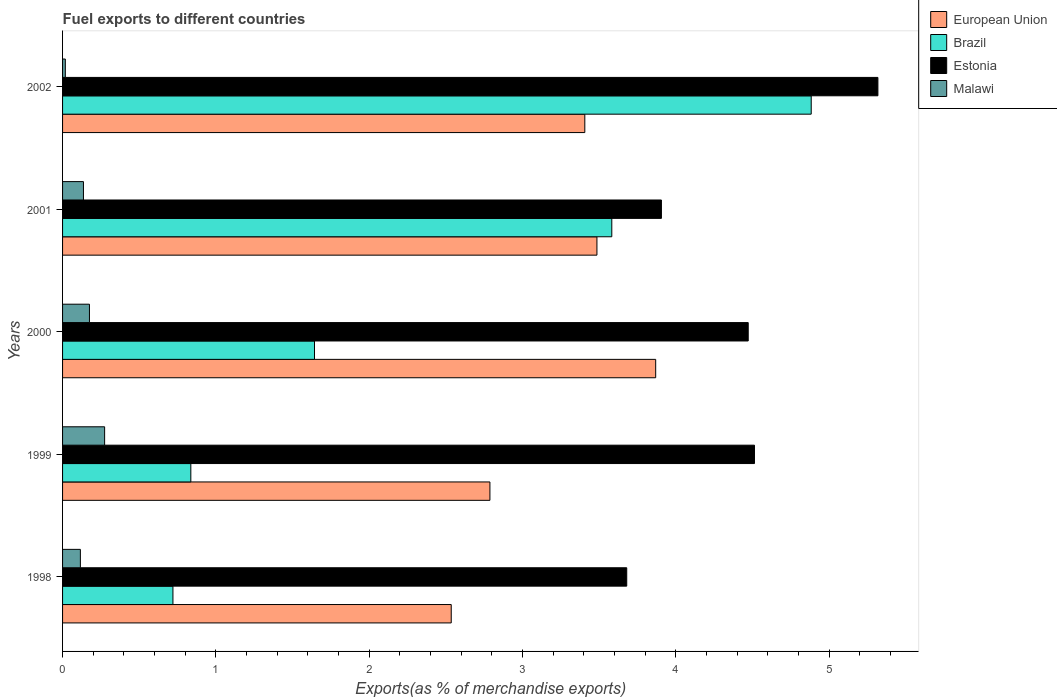Are the number of bars on each tick of the Y-axis equal?
Provide a short and direct response. Yes. How many bars are there on the 2nd tick from the bottom?
Offer a terse response. 4. In how many cases, is the number of bars for a given year not equal to the number of legend labels?
Provide a short and direct response. 0. What is the percentage of exports to different countries in European Union in 2000?
Ensure brevity in your answer.  3.87. Across all years, what is the maximum percentage of exports to different countries in European Union?
Your answer should be compact. 3.87. Across all years, what is the minimum percentage of exports to different countries in Malawi?
Keep it short and to the point. 0.02. In which year was the percentage of exports to different countries in Estonia minimum?
Your answer should be compact. 1998. What is the total percentage of exports to different countries in European Union in the graph?
Provide a succinct answer. 16.08. What is the difference between the percentage of exports to different countries in Brazil in 1998 and that in 2000?
Give a very brief answer. -0.92. What is the difference between the percentage of exports to different countries in Brazil in 1998 and the percentage of exports to different countries in Malawi in 2002?
Your answer should be compact. 0.7. What is the average percentage of exports to different countries in European Union per year?
Offer a very short reply. 3.22. In the year 2000, what is the difference between the percentage of exports to different countries in Malawi and percentage of exports to different countries in European Union?
Your answer should be compact. -3.69. In how many years, is the percentage of exports to different countries in Malawi greater than 2.6 %?
Provide a short and direct response. 0. What is the ratio of the percentage of exports to different countries in European Union in 1998 to that in 2000?
Provide a succinct answer. 0.66. Is the percentage of exports to different countries in Estonia in 2000 less than that in 2002?
Make the answer very short. Yes. What is the difference between the highest and the second highest percentage of exports to different countries in Malawi?
Offer a terse response. 0.1. What is the difference between the highest and the lowest percentage of exports to different countries in Malawi?
Give a very brief answer. 0.26. Is it the case that in every year, the sum of the percentage of exports to different countries in Brazil and percentage of exports to different countries in European Union is greater than the sum of percentage of exports to different countries in Estonia and percentage of exports to different countries in Malawi?
Offer a very short reply. No. What does the 4th bar from the top in 2000 represents?
Ensure brevity in your answer.  European Union. What does the 3rd bar from the bottom in 2000 represents?
Provide a short and direct response. Estonia. What is the difference between two consecutive major ticks on the X-axis?
Your answer should be compact. 1. Does the graph contain any zero values?
Offer a terse response. No. Does the graph contain grids?
Your response must be concise. No. Where does the legend appear in the graph?
Your response must be concise. Top right. How many legend labels are there?
Offer a terse response. 4. What is the title of the graph?
Your response must be concise. Fuel exports to different countries. What is the label or title of the X-axis?
Provide a succinct answer. Exports(as % of merchandise exports). What is the label or title of the Y-axis?
Keep it short and to the point. Years. What is the Exports(as % of merchandise exports) in European Union in 1998?
Make the answer very short. 2.54. What is the Exports(as % of merchandise exports) in Brazil in 1998?
Keep it short and to the point. 0.72. What is the Exports(as % of merchandise exports) of Estonia in 1998?
Your response must be concise. 3.68. What is the Exports(as % of merchandise exports) in Malawi in 1998?
Provide a succinct answer. 0.12. What is the Exports(as % of merchandise exports) of European Union in 1999?
Your answer should be compact. 2.79. What is the Exports(as % of merchandise exports) in Brazil in 1999?
Offer a very short reply. 0.84. What is the Exports(as % of merchandise exports) of Estonia in 1999?
Keep it short and to the point. 4.51. What is the Exports(as % of merchandise exports) of Malawi in 1999?
Offer a very short reply. 0.27. What is the Exports(as % of merchandise exports) of European Union in 2000?
Provide a succinct answer. 3.87. What is the Exports(as % of merchandise exports) of Brazil in 2000?
Your response must be concise. 1.64. What is the Exports(as % of merchandise exports) of Estonia in 2000?
Provide a succinct answer. 4.47. What is the Exports(as % of merchandise exports) in Malawi in 2000?
Provide a short and direct response. 0.18. What is the Exports(as % of merchandise exports) of European Union in 2001?
Make the answer very short. 3.49. What is the Exports(as % of merchandise exports) of Brazil in 2001?
Your answer should be very brief. 3.58. What is the Exports(as % of merchandise exports) of Estonia in 2001?
Your response must be concise. 3.91. What is the Exports(as % of merchandise exports) in Malawi in 2001?
Make the answer very short. 0.14. What is the Exports(as % of merchandise exports) of European Union in 2002?
Keep it short and to the point. 3.41. What is the Exports(as % of merchandise exports) in Brazil in 2002?
Keep it short and to the point. 4.88. What is the Exports(as % of merchandise exports) in Estonia in 2002?
Provide a succinct answer. 5.32. What is the Exports(as % of merchandise exports) of Malawi in 2002?
Ensure brevity in your answer.  0.02. Across all years, what is the maximum Exports(as % of merchandise exports) of European Union?
Keep it short and to the point. 3.87. Across all years, what is the maximum Exports(as % of merchandise exports) of Brazil?
Your answer should be very brief. 4.88. Across all years, what is the maximum Exports(as % of merchandise exports) of Estonia?
Your answer should be very brief. 5.32. Across all years, what is the maximum Exports(as % of merchandise exports) of Malawi?
Your answer should be compact. 0.27. Across all years, what is the minimum Exports(as % of merchandise exports) of European Union?
Make the answer very short. 2.54. Across all years, what is the minimum Exports(as % of merchandise exports) in Brazil?
Keep it short and to the point. 0.72. Across all years, what is the minimum Exports(as % of merchandise exports) of Estonia?
Your answer should be compact. 3.68. Across all years, what is the minimum Exports(as % of merchandise exports) of Malawi?
Make the answer very short. 0.02. What is the total Exports(as % of merchandise exports) of European Union in the graph?
Keep it short and to the point. 16.08. What is the total Exports(as % of merchandise exports) in Brazil in the graph?
Make the answer very short. 11.67. What is the total Exports(as % of merchandise exports) of Estonia in the graph?
Ensure brevity in your answer.  21.89. What is the total Exports(as % of merchandise exports) in Malawi in the graph?
Provide a succinct answer. 0.72. What is the difference between the Exports(as % of merchandise exports) in European Union in 1998 and that in 1999?
Make the answer very short. -0.25. What is the difference between the Exports(as % of merchandise exports) in Brazil in 1998 and that in 1999?
Provide a succinct answer. -0.12. What is the difference between the Exports(as % of merchandise exports) in Estonia in 1998 and that in 1999?
Offer a very short reply. -0.83. What is the difference between the Exports(as % of merchandise exports) in Malawi in 1998 and that in 1999?
Your answer should be very brief. -0.16. What is the difference between the Exports(as % of merchandise exports) in European Union in 1998 and that in 2000?
Provide a succinct answer. -1.33. What is the difference between the Exports(as % of merchandise exports) in Brazil in 1998 and that in 2000?
Ensure brevity in your answer.  -0.92. What is the difference between the Exports(as % of merchandise exports) of Estonia in 1998 and that in 2000?
Your response must be concise. -0.79. What is the difference between the Exports(as % of merchandise exports) in Malawi in 1998 and that in 2000?
Offer a very short reply. -0.06. What is the difference between the Exports(as % of merchandise exports) in European Union in 1998 and that in 2001?
Make the answer very short. -0.95. What is the difference between the Exports(as % of merchandise exports) of Brazil in 1998 and that in 2001?
Ensure brevity in your answer.  -2.86. What is the difference between the Exports(as % of merchandise exports) in Estonia in 1998 and that in 2001?
Offer a terse response. -0.23. What is the difference between the Exports(as % of merchandise exports) in Malawi in 1998 and that in 2001?
Your answer should be very brief. -0.02. What is the difference between the Exports(as % of merchandise exports) of European Union in 1998 and that in 2002?
Keep it short and to the point. -0.87. What is the difference between the Exports(as % of merchandise exports) of Brazil in 1998 and that in 2002?
Your answer should be compact. -4.16. What is the difference between the Exports(as % of merchandise exports) in Estonia in 1998 and that in 2002?
Provide a succinct answer. -1.64. What is the difference between the Exports(as % of merchandise exports) in Malawi in 1998 and that in 2002?
Give a very brief answer. 0.1. What is the difference between the Exports(as % of merchandise exports) in European Union in 1999 and that in 2000?
Provide a short and direct response. -1.08. What is the difference between the Exports(as % of merchandise exports) of Brazil in 1999 and that in 2000?
Give a very brief answer. -0.81. What is the difference between the Exports(as % of merchandise exports) in Estonia in 1999 and that in 2000?
Ensure brevity in your answer.  0.04. What is the difference between the Exports(as % of merchandise exports) in Malawi in 1999 and that in 2000?
Offer a very short reply. 0.1. What is the difference between the Exports(as % of merchandise exports) in European Union in 1999 and that in 2001?
Keep it short and to the point. -0.7. What is the difference between the Exports(as % of merchandise exports) of Brazil in 1999 and that in 2001?
Offer a terse response. -2.75. What is the difference between the Exports(as % of merchandise exports) in Estonia in 1999 and that in 2001?
Your answer should be very brief. 0.61. What is the difference between the Exports(as % of merchandise exports) of Malawi in 1999 and that in 2001?
Provide a succinct answer. 0.14. What is the difference between the Exports(as % of merchandise exports) in European Union in 1999 and that in 2002?
Your response must be concise. -0.62. What is the difference between the Exports(as % of merchandise exports) in Brazil in 1999 and that in 2002?
Your answer should be very brief. -4.05. What is the difference between the Exports(as % of merchandise exports) in Estonia in 1999 and that in 2002?
Provide a succinct answer. -0.81. What is the difference between the Exports(as % of merchandise exports) of Malawi in 1999 and that in 2002?
Provide a succinct answer. 0.26. What is the difference between the Exports(as % of merchandise exports) of European Union in 2000 and that in 2001?
Offer a very short reply. 0.38. What is the difference between the Exports(as % of merchandise exports) of Brazil in 2000 and that in 2001?
Ensure brevity in your answer.  -1.94. What is the difference between the Exports(as % of merchandise exports) of Estonia in 2000 and that in 2001?
Your response must be concise. 0.57. What is the difference between the Exports(as % of merchandise exports) in Malawi in 2000 and that in 2001?
Ensure brevity in your answer.  0.04. What is the difference between the Exports(as % of merchandise exports) in European Union in 2000 and that in 2002?
Keep it short and to the point. 0.46. What is the difference between the Exports(as % of merchandise exports) in Brazil in 2000 and that in 2002?
Keep it short and to the point. -3.24. What is the difference between the Exports(as % of merchandise exports) of Estonia in 2000 and that in 2002?
Your answer should be compact. -0.85. What is the difference between the Exports(as % of merchandise exports) of Malawi in 2000 and that in 2002?
Give a very brief answer. 0.16. What is the difference between the Exports(as % of merchandise exports) in European Union in 2001 and that in 2002?
Your answer should be very brief. 0.08. What is the difference between the Exports(as % of merchandise exports) in Brazil in 2001 and that in 2002?
Keep it short and to the point. -1.3. What is the difference between the Exports(as % of merchandise exports) in Estonia in 2001 and that in 2002?
Give a very brief answer. -1.41. What is the difference between the Exports(as % of merchandise exports) of Malawi in 2001 and that in 2002?
Provide a succinct answer. 0.12. What is the difference between the Exports(as % of merchandise exports) in European Union in 1998 and the Exports(as % of merchandise exports) in Brazil in 1999?
Your response must be concise. 1.7. What is the difference between the Exports(as % of merchandise exports) in European Union in 1998 and the Exports(as % of merchandise exports) in Estonia in 1999?
Your response must be concise. -1.98. What is the difference between the Exports(as % of merchandise exports) in European Union in 1998 and the Exports(as % of merchandise exports) in Malawi in 1999?
Keep it short and to the point. 2.26. What is the difference between the Exports(as % of merchandise exports) in Brazil in 1998 and the Exports(as % of merchandise exports) in Estonia in 1999?
Provide a short and direct response. -3.79. What is the difference between the Exports(as % of merchandise exports) of Brazil in 1998 and the Exports(as % of merchandise exports) of Malawi in 1999?
Your answer should be compact. 0.45. What is the difference between the Exports(as % of merchandise exports) in Estonia in 1998 and the Exports(as % of merchandise exports) in Malawi in 1999?
Provide a short and direct response. 3.41. What is the difference between the Exports(as % of merchandise exports) in European Union in 1998 and the Exports(as % of merchandise exports) in Brazil in 2000?
Give a very brief answer. 0.89. What is the difference between the Exports(as % of merchandise exports) of European Union in 1998 and the Exports(as % of merchandise exports) of Estonia in 2000?
Provide a succinct answer. -1.94. What is the difference between the Exports(as % of merchandise exports) of European Union in 1998 and the Exports(as % of merchandise exports) of Malawi in 2000?
Provide a succinct answer. 2.36. What is the difference between the Exports(as % of merchandise exports) in Brazil in 1998 and the Exports(as % of merchandise exports) in Estonia in 2000?
Offer a very short reply. -3.75. What is the difference between the Exports(as % of merchandise exports) in Brazil in 1998 and the Exports(as % of merchandise exports) in Malawi in 2000?
Provide a succinct answer. 0.54. What is the difference between the Exports(as % of merchandise exports) in Estonia in 1998 and the Exports(as % of merchandise exports) in Malawi in 2000?
Offer a very short reply. 3.5. What is the difference between the Exports(as % of merchandise exports) of European Union in 1998 and the Exports(as % of merchandise exports) of Brazil in 2001?
Your answer should be compact. -1.05. What is the difference between the Exports(as % of merchandise exports) in European Union in 1998 and the Exports(as % of merchandise exports) in Estonia in 2001?
Your response must be concise. -1.37. What is the difference between the Exports(as % of merchandise exports) of European Union in 1998 and the Exports(as % of merchandise exports) of Malawi in 2001?
Ensure brevity in your answer.  2.4. What is the difference between the Exports(as % of merchandise exports) in Brazil in 1998 and the Exports(as % of merchandise exports) in Estonia in 2001?
Make the answer very short. -3.19. What is the difference between the Exports(as % of merchandise exports) in Brazil in 1998 and the Exports(as % of merchandise exports) in Malawi in 2001?
Offer a very short reply. 0.58. What is the difference between the Exports(as % of merchandise exports) in Estonia in 1998 and the Exports(as % of merchandise exports) in Malawi in 2001?
Offer a terse response. 3.54. What is the difference between the Exports(as % of merchandise exports) in European Union in 1998 and the Exports(as % of merchandise exports) in Brazil in 2002?
Your answer should be very brief. -2.35. What is the difference between the Exports(as % of merchandise exports) of European Union in 1998 and the Exports(as % of merchandise exports) of Estonia in 2002?
Your answer should be very brief. -2.78. What is the difference between the Exports(as % of merchandise exports) in European Union in 1998 and the Exports(as % of merchandise exports) in Malawi in 2002?
Offer a very short reply. 2.52. What is the difference between the Exports(as % of merchandise exports) in Brazil in 1998 and the Exports(as % of merchandise exports) in Estonia in 2002?
Your answer should be very brief. -4.6. What is the difference between the Exports(as % of merchandise exports) in Brazil in 1998 and the Exports(as % of merchandise exports) in Malawi in 2002?
Give a very brief answer. 0.7. What is the difference between the Exports(as % of merchandise exports) in Estonia in 1998 and the Exports(as % of merchandise exports) in Malawi in 2002?
Keep it short and to the point. 3.66. What is the difference between the Exports(as % of merchandise exports) in European Union in 1999 and the Exports(as % of merchandise exports) in Brazil in 2000?
Provide a short and direct response. 1.14. What is the difference between the Exports(as % of merchandise exports) of European Union in 1999 and the Exports(as % of merchandise exports) of Estonia in 2000?
Make the answer very short. -1.68. What is the difference between the Exports(as % of merchandise exports) in European Union in 1999 and the Exports(as % of merchandise exports) in Malawi in 2000?
Provide a succinct answer. 2.61. What is the difference between the Exports(as % of merchandise exports) of Brazil in 1999 and the Exports(as % of merchandise exports) of Estonia in 2000?
Keep it short and to the point. -3.64. What is the difference between the Exports(as % of merchandise exports) in Brazil in 1999 and the Exports(as % of merchandise exports) in Malawi in 2000?
Offer a terse response. 0.66. What is the difference between the Exports(as % of merchandise exports) in Estonia in 1999 and the Exports(as % of merchandise exports) in Malawi in 2000?
Your answer should be very brief. 4.34. What is the difference between the Exports(as % of merchandise exports) of European Union in 1999 and the Exports(as % of merchandise exports) of Brazil in 2001?
Offer a very short reply. -0.79. What is the difference between the Exports(as % of merchandise exports) in European Union in 1999 and the Exports(as % of merchandise exports) in Estonia in 2001?
Offer a very short reply. -1.12. What is the difference between the Exports(as % of merchandise exports) of European Union in 1999 and the Exports(as % of merchandise exports) of Malawi in 2001?
Provide a short and direct response. 2.65. What is the difference between the Exports(as % of merchandise exports) of Brazil in 1999 and the Exports(as % of merchandise exports) of Estonia in 2001?
Keep it short and to the point. -3.07. What is the difference between the Exports(as % of merchandise exports) of Brazil in 1999 and the Exports(as % of merchandise exports) of Malawi in 2001?
Your answer should be compact. 0.7. What is the difference between the Exports(as % of merchandise exports) in Estonia in 1999 and the Exports(as % of merchandise exports) in Malawi in 2001?
Your answer should be compact. 4.38. What is the difference between the Exports(as % of merchandise exports) of European Union in 1999 and the Exports(as % of merchandise exports) of Brazil in 2002?
Keep it short and to the point. -2.1. What is the difference between the Exports(as % of merchandise exports) of European Union in 1999 and the Exports(as % of merchandise exports) of Estonia in 2002?
Your answer should be very brief. -2.53. What is the difference between the Exports(as % of merchandise exports) in European Union in 1999 and the Exports(as % of merchandise exports) in Malawi in 2002?
Offer a very short reply. 2.77. What is the difference between the Exports(as % of merchandise exports) of Brazil in 1999 and the Exports(as % of merchandise exports) of Estonia in 2002?
Provide a short and direct response. -4.48. What is the difference between the Exports(as % of merchandise exports) in Brazil in 1999 and the Exports(as % of merchandise exports) in Malawi in 2002?
Provide a succinct answer. 0.82. What is the difference between the Exports(as % of merchandise exports) in Estonia in 1999 and the Exports(as % of merchandise exports) in Malawi in 2002?
Make the answer very short. 4.5. What is the difference between the Exports(as % of merchandise exports) in European Union in 2000 and the Exports(as % of merchandise exports) in Brazil in 2001?
Make the answer very short. 0.29. What is the difference between the Exports(as % of merchandise exports) in European Union in 2000 and the Exports(as % of merchandise exports) in Estonia in 2001?
Offer a terse response. -0.04. What is the difference between the Exports(as % of merchandise exports) of European Union in 2000 and the Exports(as % of merchandise exports) of Malawi in 2001?
Offer a very short reply. 3.73. What is the difference between the Exports(as % of merchandise exports) of Brazil in 2000 and the Exports(as % of merchandise exports) of Estonia in 2001?
Give a very brief answer. -2.26. What is the difference between the Exports(as % of merchandise exports) in Brazil in 2000 and the Exports(as % of merchandise exports) in Malawi in 2001?
Provide a succinct answer. 1.51. What is the difference between the Exports(as % of merchandise exports) in Estonia in 2000 and the Exports(as % of merchandise exports) in Malawi in 2001?
Offer a terse response. 4.34. What is the difference between the Exports(as % of merchandise exports) of European Union in 2000 and the Exports(as % of merchandise exports) of Brazil in 2002?
Give a very brief answer. -1.01. What is the difference between the Exports(as % of merchandise exports) of European Union in 2000 and the Exports(as % of merchandise exports) of Estonia in 2002?
Keep it short and to the point. -1.45. What is the difference between the Exports(as % of merchandise exports) of European Union in 2000 and the Exports(as % of merchandise exports) of Malawi in 2002?
Provide a succinct answer. 3.85. What is the difference between the Exports(as % of merchandise exports) of Brazil in 2000 and the Exports(as % of merchandise exports) of Estonia in 2002?
Keep it short and to the point. -3.68. What is the difference between the Exports(as % of merchandise exports) in Brazil in 2000 and the Exports(as % of merchandise exports) in Malawi in 2002?
Ensure brevity in your answer.  1.63. What is the difference between the Exports(as % of merchandise exports) of Estonia in 2000 and the Exports(as % of merchandise exports) of Malawi in 2002?
Your response must be concise. 4.45. What is the difference between the Exports(as % of merchandise exports) in European Union in 2001 and the Exports(as % of merchandise exports) in Brazil in 2002?
Offer a terse response. -1.4. What is the difference between the Exports(as % of merchandise exports) of European Union in 2001 and the Exports(as % of merchandise exports) of Estonia in 2002?
Provide a short and direct response. -1.83. What is the difference between the Exports(as % of merchandise exports) in European Union in 2001 and the Exports(as % of merchandise exports) in Malawi in 2002?
Offer a very short reply. 3.47. What is the difference between the Exports(as % of merchandise exports) of Brazil in 2001 and the Exports(as % of merchandise exports) of Estonia in 2002?
Make the answer very short. -1.74. What is the difference between the Exports(as % of merchandise exports) of Brazil in 2001 and the Exports(as % of merchandise exports) of Malawi in 2002?
Make the answer very short. 3.56. What is the difference between the Exports(as % of merchandise exports) of Estonia in 2001 and the Exports(as % of merchandise exports) of Malawi in 2002?
Your answer should be compact. 3.89. What is the average Exports(as % of merchandise exports) of European Union per year?
Your answer should be very brief. 3.22. What is the average Exports(as % of merchandise exports) in Brazil per year?
Ensure brevity in your answer.  2.33. What is the average Exports(as % of merchandise exports) in Estonia per year?
Your answer should be very brief. 4.38. What is the average Exports(as % of merchandise exports) of Malawi per year?
Your answer should be very brief. 0.14. In the year 1998, what is the difference between the Exports(as % of merchandise exports) in European Union and Exports(as % of merchandise exports) in Brazil?
Your response must be concise. 1.82. In the year 1998, what is the difference between the Exports(as % of merchandise exports) in European Union and Exports(as % of merchandise exports) in Estonia?
Make the answer very short. -1.14. In the year 1998, what is the difference between the Exports(as % of merchandise exports) of European Union and Exports(as % of merchandise exports) of Malawi?
Your answer should be compact. 2.42. In the year 1998, what is the difference between the Exports(as % of merchandise exports) in Brazil and Exports(as % of merchandise exports) in Estonia?
Provide a succinct answer. -2.96. In the year 1998, what is the difference between the Exports(as % of merchandise exports) in Brazil and Exports(as % of merchandise exports) in Malawi?
Provide a succinct answer. 0.6. In the year 1998, what is the difference between the Exports(as % of merchandise exports) of Estonia and Exports(as % of merchandise exports) of Malawi?
Your response must be concise. 3.56. In the year 1999, what is the difference between the Exports(as % of merchandise exports) in European Union and Exports(as % of merchandise exports) in Brazil?
Give a very brief answer. 1.95. In the year 1999, what is the difference between the Exports(as % of merchandise exports) of European Union and Exports(as % of merchandise exports) of Estonia?
Make the answer very short. -1.73. In the year 1999, what is the difference between the Exports(as % of merchandise exports) of European Union and Exports(as % of merchandise exports) of Malawi?
Provide a short and direct response. 2.51. In the year 1999, what is the difference between the Exports(as % of merchandise exports) in Brazil and Exports(as % of merchandise exports) in Estonia?
Your response must be concise. -3.68. In the year 1999, what is the difference between the Exports(as % of merchandise exports) in Brazil and Exports(as % of merchandise exports) in Malawi?
Provide a succinct answer. 0.56. In the year 1999, what is the difference between the Exports(as % of merchandise exports) in Estonia and Exports(as % of merchandise exports) in Malawi?
Your response must be concise. 4.24. In the year 2000, what is the difference between the Exports(as % of merchandise exports) in European Union and Exports(as % of merchandise exports) in Brazil?
Make the answer very short. 2.23. In the year 2000, what is the difference between the Exports(as % of merchandise exports) in European Union and Exports(as % of merchandise exports) in Estonia?
Give a very brief answer. -0.6. In the year 2000, what is the difference between the Exports(as % of merchandise exports) of European Union and Exports(as % of merchandise exports) of Malawi?
Provide a short and direct response. 3.69. In the year 2000, what is the difference between the Exports(as % of merchandise exports) of Brazil and Exports(as % of merchandise exports) of Estonia?
Your answer should be very brief. -2.83. In the year 2000, what is the difference between the Exports(as % of merchandise exports) in Brazil and Exports(as % of merchandise exports) in Malawi?
Your answer should be compact. 1.47. In the year 2000, what is the difference between the Exports(as % of merchandise exports) in Estonia and Exports(as % of merchandise exports) in Malawi?
Ensure brevity in your answer.  4.3. In the year 2001, what is the difference between the Exports(as % of merchandise exports) in European Union and Exports(as % of merchandise exports) in Brazil?
Provide a short and direct response. -0.1. In the year 2001, what is the difference between the Exports(as % of merchandise exports) of European Union and Exports(as % of merchandise exports) of Estonia?
Your answer should be compact. -0.42. In the year 2001, what is the difference between the Exports(as % of merchandise exports) of European Union and Exports(as % of merchandise exports) of Malawi?
Make the answer very short. 3.35. In the year 2001, what is the difference between the Exports(as % of merchandise exports) in Brazil and Exports(as % of merchandise exports) in Estonia?
Ensure brevity in your answer.  -0.32. In the year 2001, what is the difference between the Exports(as % of merchandise exports) of Brazil and Exports(as % of merchandise exports) of Malawi?
Keep it short and to the point. 3.45. In the year 2001, what is the difference between the Exports(as % of merchandise exports) in Estonia and Exports(as % of merchandise exports) in Malawi?
Give a very brief answer. 3.77. In the year 2002, what is the difference between the Exports(as % of merchandise exports) of European Union and Exports(as % of merchandise exports) of Brazil?
Ensure brevity in your answer.  -1.48. In the year 2002, what is the difference between the Exports(as % of merchandise exports) of European Union and Exports(as % of merchandise exports) of Estonia?
Your answer should be compact. -1.91. In the year 2002, what is the difference between the Exports(as % of merchandise exports) of European Union and Exports(as % of merchandise exports) of Malawi?
Offer a terse response. 3.39. In the year 2002, what is the difference between the Exports(as % of merchandise exports) of Brazil and Exports(as % of merchandise exports) of Estonia?
Offer a very short reply. -0.43. In the year 2002, what is the difference between the Exports(as % of merchandise exports) of Brazil and Exports(as % of merchandise exports) of Malawi?
Provide a short and direct response. 4.87. In the year 2002, what is the difference between the Exports(as % of merchandise exports) in Estonia and Exports(as % of merchandise exports) in Malawi?
Provide a succinct answer. 5.3. What is the ratio of the Exports(as % of merchandise exports) of European Union in 1998 to that in 1999?
Make the answer very short. 0.91. What is the ratio of the Exports(as % of merchandise exports) in Brazil in 1998 to that in 1999?
Offer a terse response. 0.86. What is the ratio of the Exports(as % of merchandise exports) in Estonia in 1998 to that in 1999?
Your response must be concise. 0.82. What is the ratio of the Exports(as % of merchandise exports) of Malawi in 1998 to that in 1999?
Offer a very short reply. 0.42. What is the ratio of the Exports(as % of merchandise exports) of European Union in 1998 to that in 2000?
Give a very brief answer. 0.66. What is the ratio of the Exports(as % of merchandise exports) in Brazil in 1998 to that in 2000?
Provide a short and direct response. 0.44. What is the ratio of the Exports(as % of merchandise exports) of Estonia in 1998 to that in 2000?
Provide a succinct answer. 0.82. What is the ratio of the Exports(as % of merchandise exports) of Malawi in 1998 to that in 2000?
Your answer should be compact. 0.66. What is the ratio of the Exports(as % of merchandise exports) of European Union in 1998 to that in 2001?
Ensure brevity in your answer.  0.73. What is the ratio of the Exports(as % of merchandise exports) of Brazil in 1998 to that in 2001?
Keep it short and to the point. 0.2. What is the ratio of the Exports(as % of merchandise exports) of Estonia in 1998 to that in 2001?
Your response must be concise. 0.94. What is the ratio of the Exports(as % of merchandise exports) in Malawi in 1998 to that in 2001?
Give a very brief answer. 0.85. What is the ratio of the Exports(as % of merchandise exports) of European Union in 1998 to that in 2002?
Offer a terse response. 0.74. What is the ratio of the Exports(as % of merchandise exports) in Brazil in 1998 to that in 2002?
Provide a succinct answer. 0.15. What is the ratio of the Exports(as % of merchandise exports) in Estonia in 1998 to that in 2002?
Keep it short and to the point. 0.69. What is the ratio of the Exports(as % of merchandise exports) in Malawi in 1998 to that in 2002?
Provide a short and direct response. 6.44. What is the ratio of the Exports(as % of merchandise exports) of European Union in 1999 to that in 2000?
Make the answer very short. 0.72. What is the ratio of the Exports(as % of merchandise exports) in Brazil in 1999 to that in 2000?
Give a very brief answer. 0.51. What is the ratio of the Exports(as % of merchandise exports) of Estonia in 1999 to that in 2000?
Offer a very short reply. 1.01. What is the ratio of the Exports(as % of merchandise exports) in Malawi in 1999 to that in 2000?
Offer a terse response. 1.56. What is the ratio of the Exports(as % of merchandise exports) in European Union in 1999 to that in 2001?
Ensure brevity in your answer.  0.8. What is the ratio of the Exports(as % of merchandise exports) in Brazil in 1999 to that in 2001?
Ensure brevity in your answer.  0.23. What is the ratio of the Exports(as % of merchandise exports) of Estonia in 1999 to that in 2001?
Give a very brief answer. 1.16. What is the ratio of the Exports(as % of merchandise exports) of Malawi in 1999 to that in 2001?
Give a very brief answer. 2.01. What is the ratio of the Exports(as % of merchandise exports) of European Union in 1999 to that in 2002?
Offer a very short reply. 0.82. What is the ratio of the Exports(as % of merchandise exports) in Brazil in 1999 to that in 2002?
Your answer should be compact. 0.17. What is the ratio of the Exports(as % of merchandise exports) in Estonia in 1999 to that in 2002?
Offer a terse response. 0.85. What is the ratio of the Exports(as % of merchandise exports) of Malawi in 1999 to that in 2002?
Provide a succinct answer. 15.21. What is the ratio of the Exports(as % of merchandise exports) in European Union in 2000 to that in 2001?
Provide a succinct answer. 1.11. What is the ratio of the Exports(as % of merchandise exports) of Brazil in 2000 to that in 2001?
Provide a succinct answer. 0.46. What is the ratio of the Exports(as % of merchandise exports) of Estonia in 2000 to that in 2001?
Provide a succinct answer. 1.14. What is the ratio of the Exports(as % of merchandise exports) in Malawi in 2000 to that in 2001?
Your answer should be compact. 1.29. What is the ratio of the Exports(as % of merchandise exports) of European Union in 2000 to that in 2002?
Your answer should be compact. 1.14. What is the ratio of the Exports(as % of merchandise exports) in Brazil in 2000 to that in 2002?
Your answer should be very brief. 0.34. What is the ratio of the Exports(as % of merchandise exports) of Estonia in 2000 to that in 2002?
Offer a very short reply. 0.84. What is the ratio of the Exports(as % of merchandise exports) in Malawi in 2000 to that in 2002?
Provide a short and direct response. 9.72. What is the ratio of the Exports(as % of merchandise exports) in European Union in 2001 to that in 2002?
Provide a short and direct response. 1.02. What is the ratio of the Exports(as % of merchandise exports) in Brazil in 2001 to that in 2002?
Provide a succinct answer. 0.73. What is the ratio of the Exports(as % of merchandise exports) of Estonia in 2001 to that in 2002?
Give a very brief answer. 0.73. What is the ratio of the Exports(as % of merchandise exports) in Malawi in 2001 to that in 2002?
Ensure brevity in your answer.  7.55. What is the difference between the highest and the second highest Exports(as % of merchandise exports) in European Union?
Your answer should be compact. 0.38. What is the difference between the highest and the second highest Exports(as % of merchandise exports) of Brazil?
Give a very brief answer. 1.3. What is the difference between the highest and the second highest Exports(as % of merchandise exports) of Estonia?
Provide a short and direct response. 0.81. What is the difference between the highest and the second highest Exports(as % of merchandise exports) in Malawi?
Your answer should be compact. 0.1. What is the difference between the highest and the lowest Exports(as % of merchandise exports) in European Union?
Make the answer very short. 1.33. What is the difference between the highest and the lowest Exports(as % of merchandise exports) of Brazil?
Offer a very short reply. 4.16. What is the difference between the highest and the lowest Exports(as % of merchandise exports) in Estonia?
Your response must be concise. 1.64. What is the difference between the highest and the lowest Exports(as % of merchandise exports) in Malawi?
Ensure brevity in your answer.  0.26. 